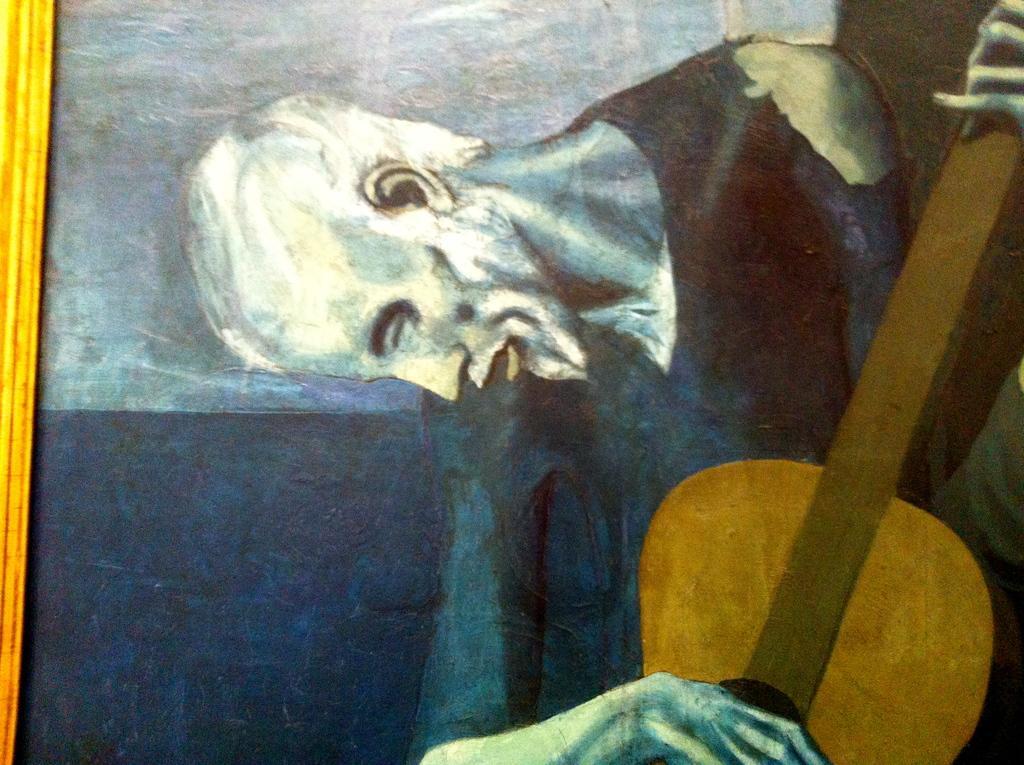How would you summarize this image in a sentence or two? As we can see in the image there is a photo frame. In photo frame there is a man holding guitar. 